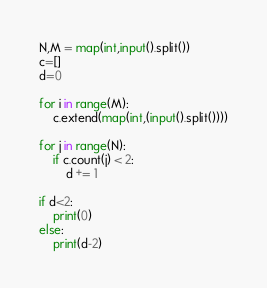<code> <loc_0><loc_0><loc_500><loc_500><_Python_>N,M = map(int,input().split())
c=[]
d=0

for i in range(M):
    c.extend(map(int,(input().split())))

for j in range(N):
    if c.count(j) < 2:
        d += 1

if d<2:
    print(0)
else:
    print(d-2)</code> 